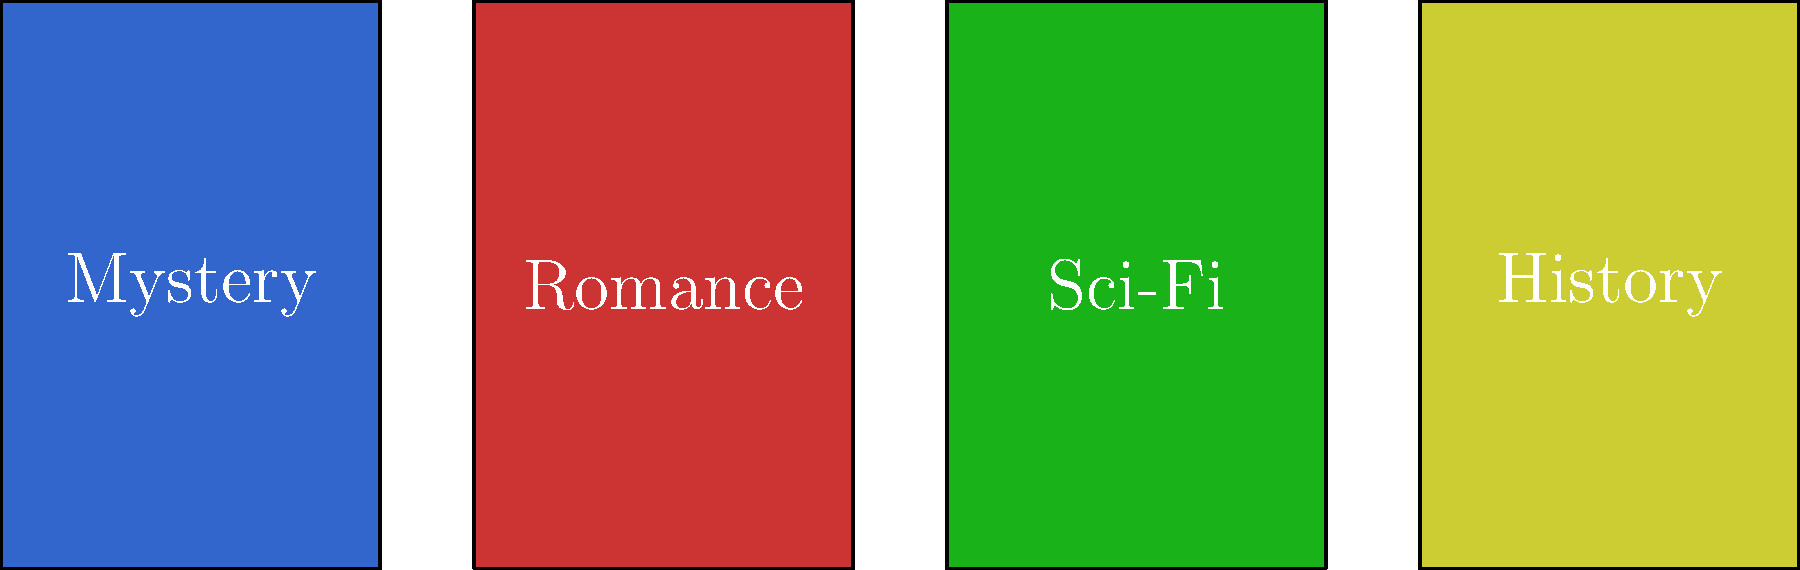Basandoti sui colori e sui layout delle copertine dei libri mostrati, quale genere letterario è rappresentato dalla copertina di colore verde? Per rispondere a questa domanda, dobbiamo analizzare le copertine dei libri presentate nell'immagine e associare i colori ai rispettivi generi letterari:

1. La prima copertina (da sinistra) è di colore blu scuro ed è etichettata come "Mystery".
2. La seconda copertina è di colore rosso ed è etichettata come "Romance".
3. La terza copertina è di colore verde ed è etichettata come "Sci-Fi".
4. La quarta copertina è di colore giallo ed è etichettata come "History".

La domanda chiede specificamente quale genere letterario è rappresentato dalla copertina di colore verde. Osservando l'immagine, possiamo vedere che la copertina verde corrisponde al genere "Sci-Fi" (Fantascienza).

Questa associazione tra il colore verde e la fantascienza è spesso utilizzata nel design delle copertine dei libri per evocare sensazioni di stranezza, alieni o tecnologia avanzata, temi comuni nel genere della fantascienza.
Answer: Sci-Fi 